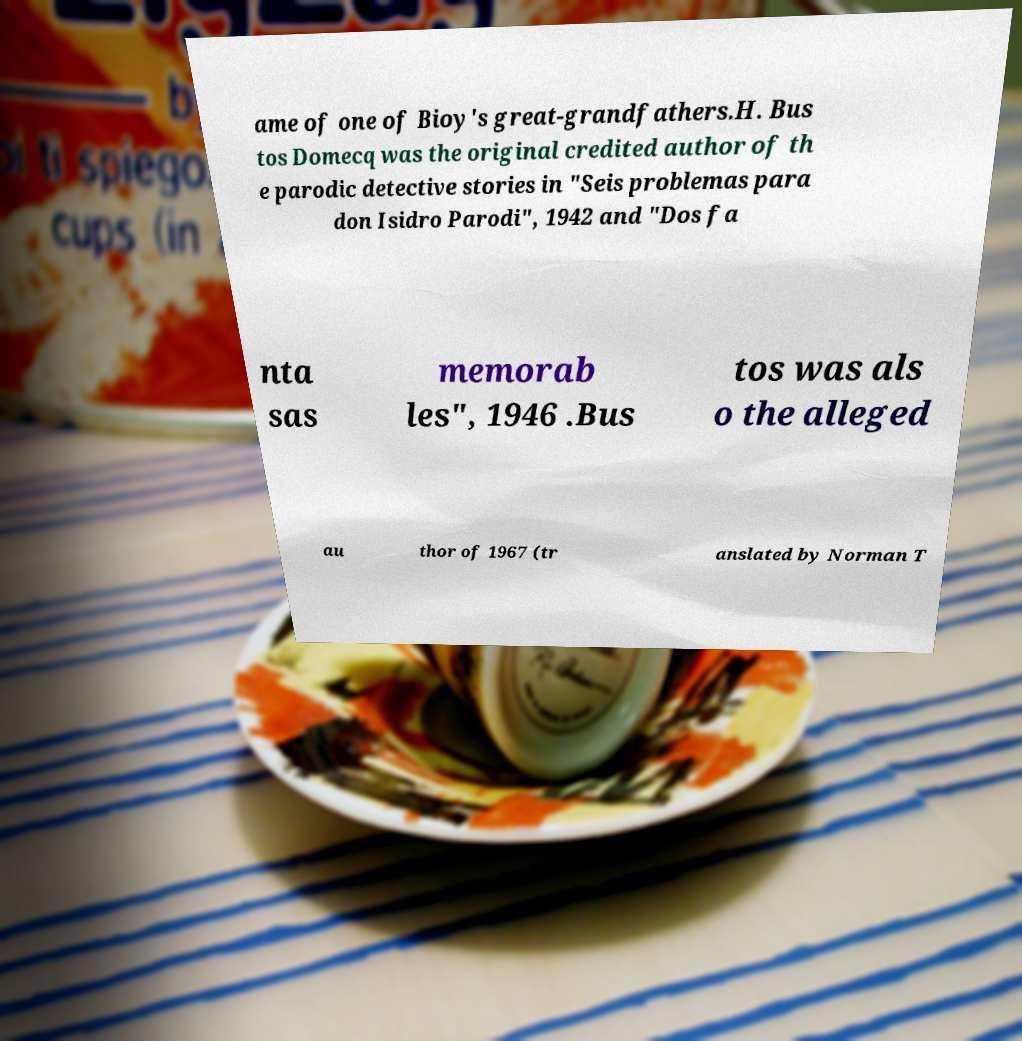Please read and relay the text visible in this image. What does it say? ame of one of Bioy's great-grandfathers.H. Bus tos Domecq was the original credited author of th e parodic detective stories in "Seis problemas para don Isidro Parodi", 1942 and "Dos fa nta sas memorab les", 1946 .Bus tos was als o the alleged au thor of 1967 (tr anslated by Norman T 